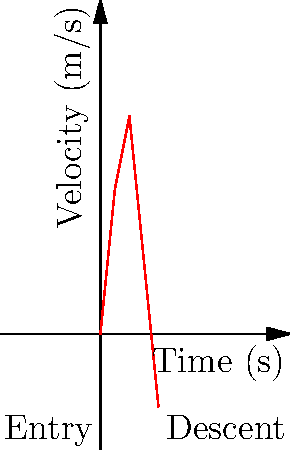The graph shows the velocity of a diver during a 4-second dive. Calculate the diver's average acceleration during the first 2 seconds of the dive. What does this tell you about the diver's motion during this phase? To solve this problem, we need to follow these steps:

1) The average acceleration is given by the formula:
   $$a_{avg} = \frac{\Delta v}{\Delta t}$$
   where $\Delta v$ is the change in velocity and $\Delta t$ is the change in time.

2) From the graph, we can see that:
   - At $t = 0$ s, $v = 0$ m/s
   - At $t = 2$ s, $v = 15$ m/s

3) Therefore:
   $\Delta v = 15 - 0 = 15$ m/s
   $\Delta t = 2 - 0 = 2$ s

4) Substituting these values into our formula:
   $$a_{avg} = \frac{15}{2} = 7.5 \text{ m/s}^2$$

5) Interpreting this result:
   The positive acceleration indicates that the diver's velocity is increasing during this phase. This corresponds to the diver's initial jump and descent into the water, where they are gaining speed due to gravity and their initial push off the platform.
Answer: $7.5 \text{ m/s}^2$; The diver's velocity is increasing. 